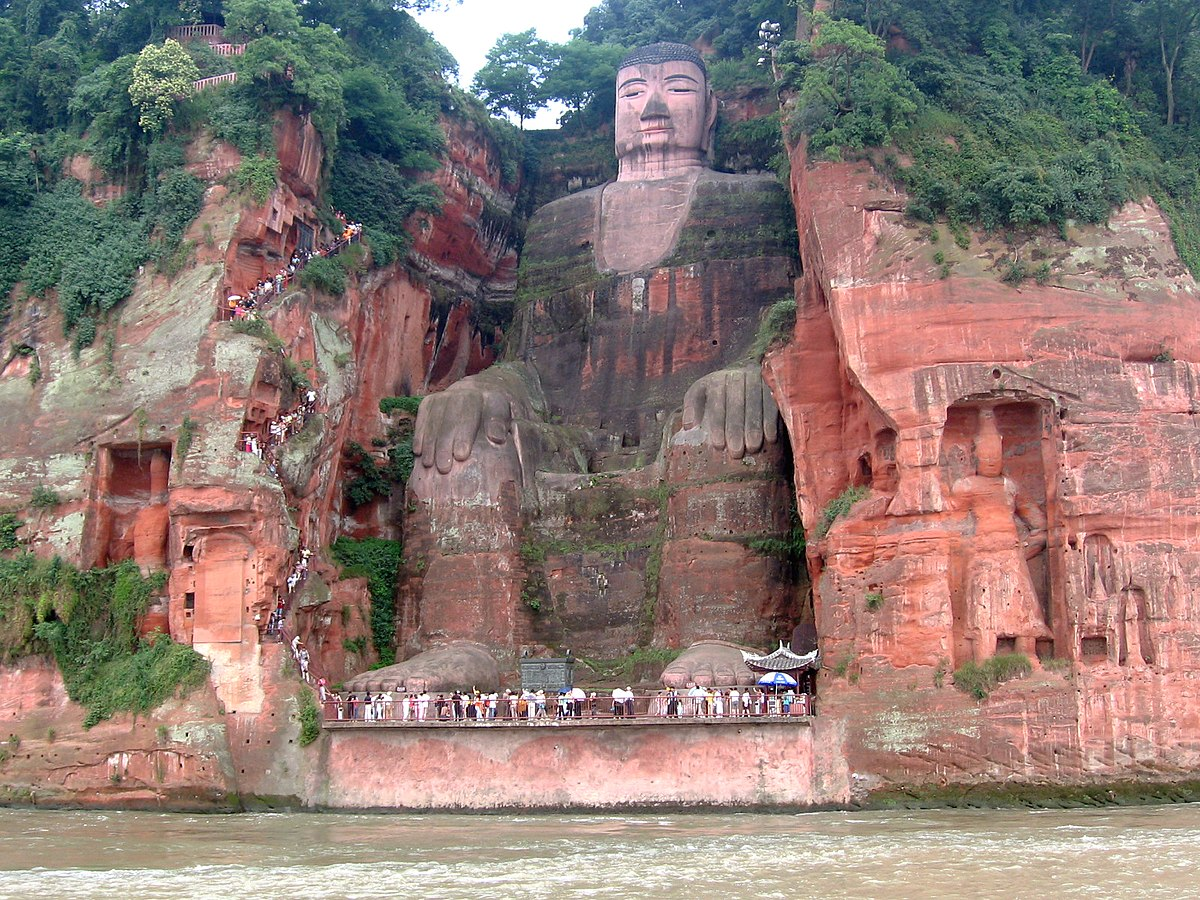What do you think is going on in this snapshot? This image showcases the stunning Leshan Giant Buddha in Sichuan, China. Carved from the cliff face, this colossal statue reaches a height of 71 meters, making it one of the largest Buddha statues in the world. The Buddha is depicted sitting, with intricate details visible on its face and robes, suggesting serenity and a meditative state. You can also see a multitude of visitors on the platforms carved into the cliff, emphasizing the scale and the popularity of this sacred site. The lush greenery surrounding the area not only enhances the beauty but also indicates the rich biodiversity of this region. This site serves not just as a significant spiritual symbol but also as a remarkable example of artistic craftsmanship and ancient Chinese engineering. 